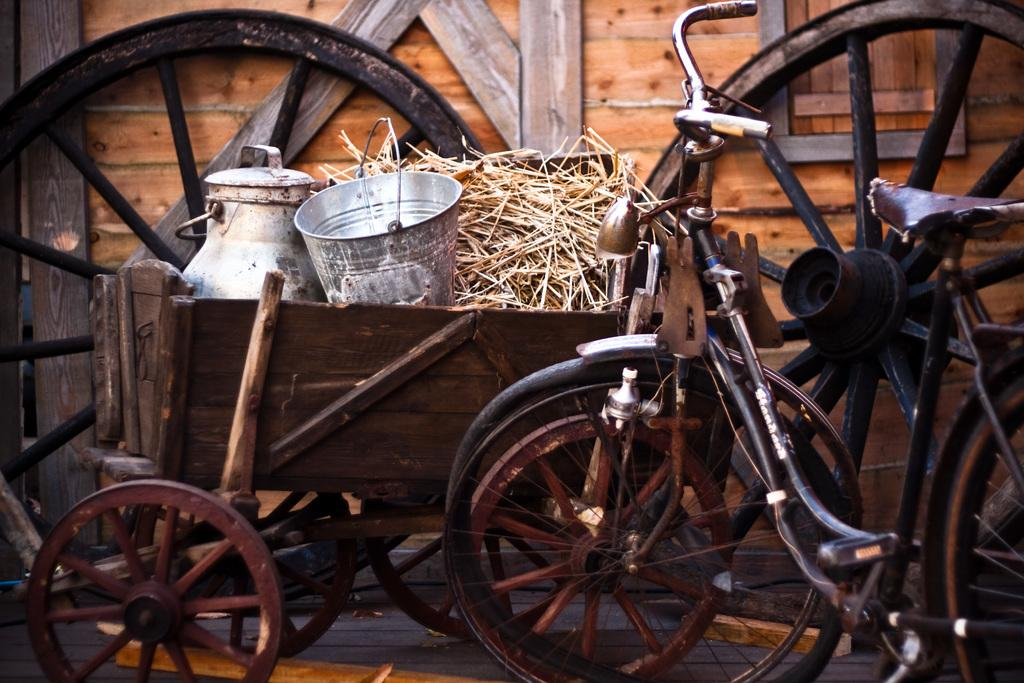What type of vehicles are in the image? There are bicycles in the image. What objects are in front of the bicycles? There are two cans in front of the bicycles. What type of vegetation is present in the image? There is dried grass in the image. What type of material is used for the wall in the background? There is a wooden wall in the background of the image. How many rabbits are hiding behind the wooden wall in the image? There are no rabbits present in the image; it only features bicycles, cans, dried grass, and a wooden wall. 